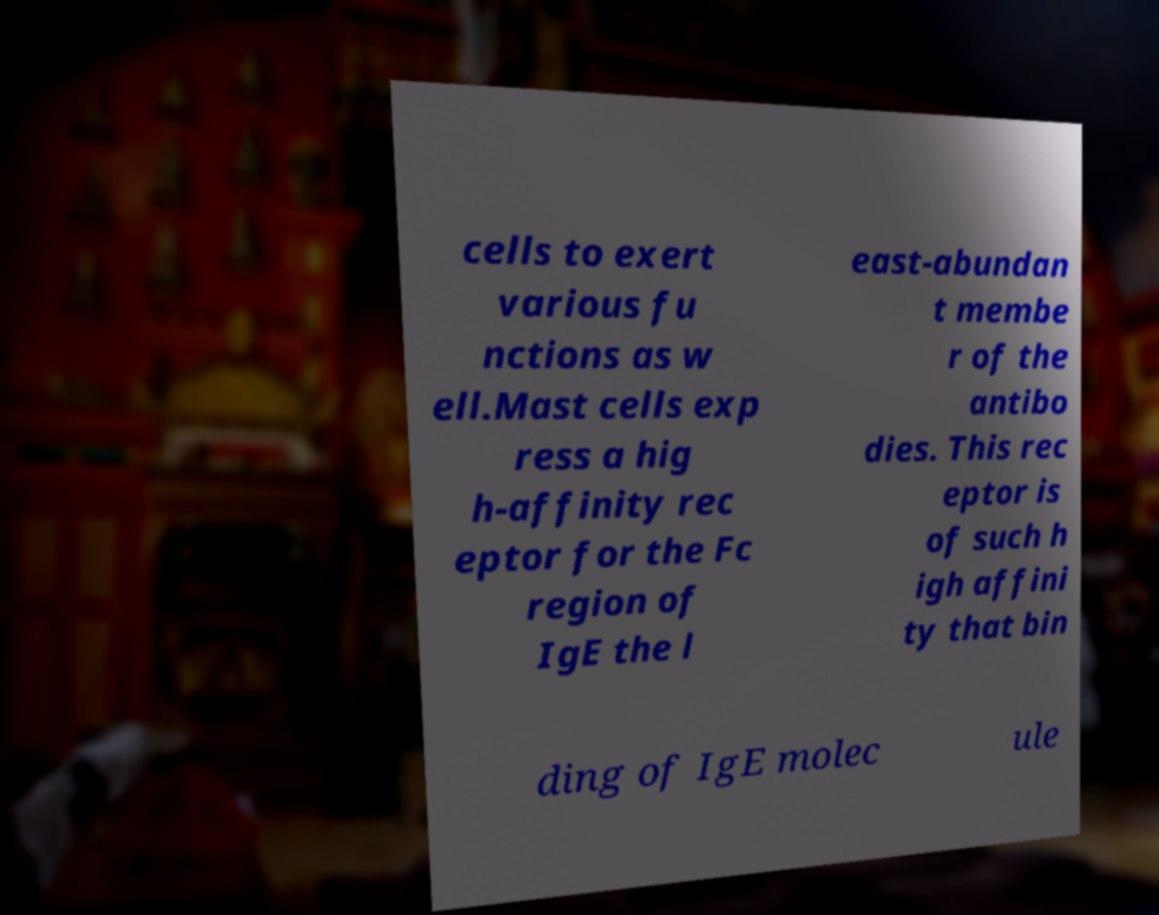Please identify and transcribe the text found in this image. cells to exert various fu nctions as w ell.Mast cells exp ress a hig h-affinity rec eptor for the Fc region of IgE the l east-abundan t membe r of the antibo dies. This rec eptor is of such h igh affini ty that bin ding of IgE molec ule 